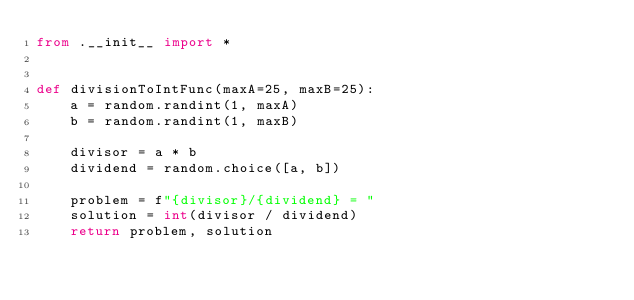Convert code to text. <code><loc_0><loc_0><loc_500><loc_500><_Python_>from .__init__ import *


def divisionToIntFunc(maxA=25, maxB=25):
    a = random.randint(1, maxA)
    b = random.randint(1, maxB)

    divisor = a * b
    dividend = random.choice([a, b])
    
    problem = f"{divisor}/{dividend} = "
    solution = int(divisor / dividend)
    return problem, solution
</code> 